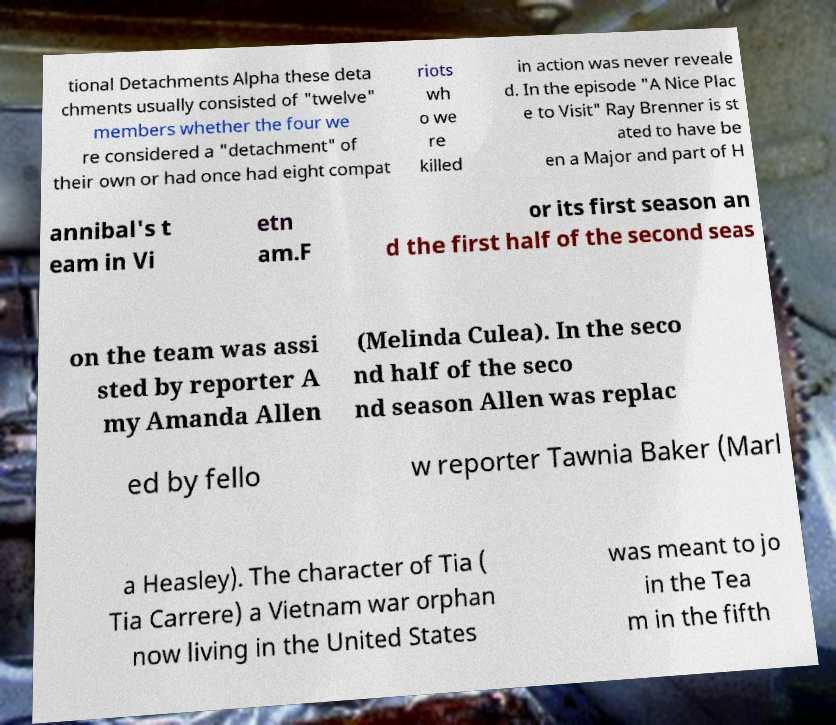Can you accurately transcribe the text from the provided image for me? tional Detachments Alpha these deta chments usually consisted of "twelve" members whether the four we re considered a "detachment" of their own or had once had eight compat riots wh o we re killed in action was never reveale d. In the episode "A Nice Plac e to Visit" Ray Brenner is st ated to have be en a Major and part of H annibal's t eam in Vi etn am.F or its first season an d the first half of the second seas on the team was assi sted by reporter A my Amanda Allen (Melinda Culea). In the seco nd half of the seco nd season Allen was replac ed by fello w reporter Tawnia Baker (Marl a Heasley). The character of Tia ( Tia Carrere) a Vietnam war orphan now living in the United States was meant to jo in the Tea m in the fifth 